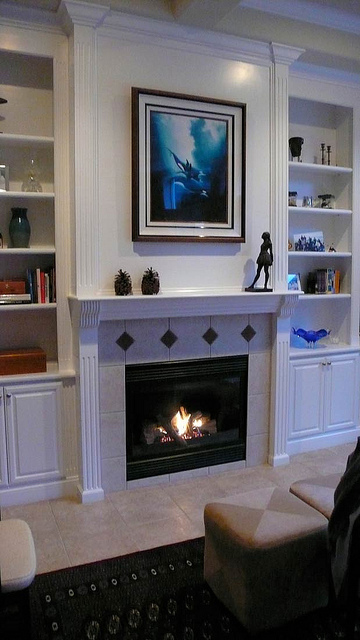<image>Why are there no cabinet doors on the right side? It is unclear why there are no cabinet doors on the right side. It could be because they didn't install them or they are open bookshelves. What is covering the window? It is ambiguous what is covering the window. It could be curtains or blinds, or there might not be anything covering the window at all. Why are there no cabinet doors on the right side? I don't know why there are no cabinet doors on the right side. It could be because they didn't install them or they might not be needed. What is covering the window? I don't know what is covering the window. It can be curtains, blinds, or nothing. 